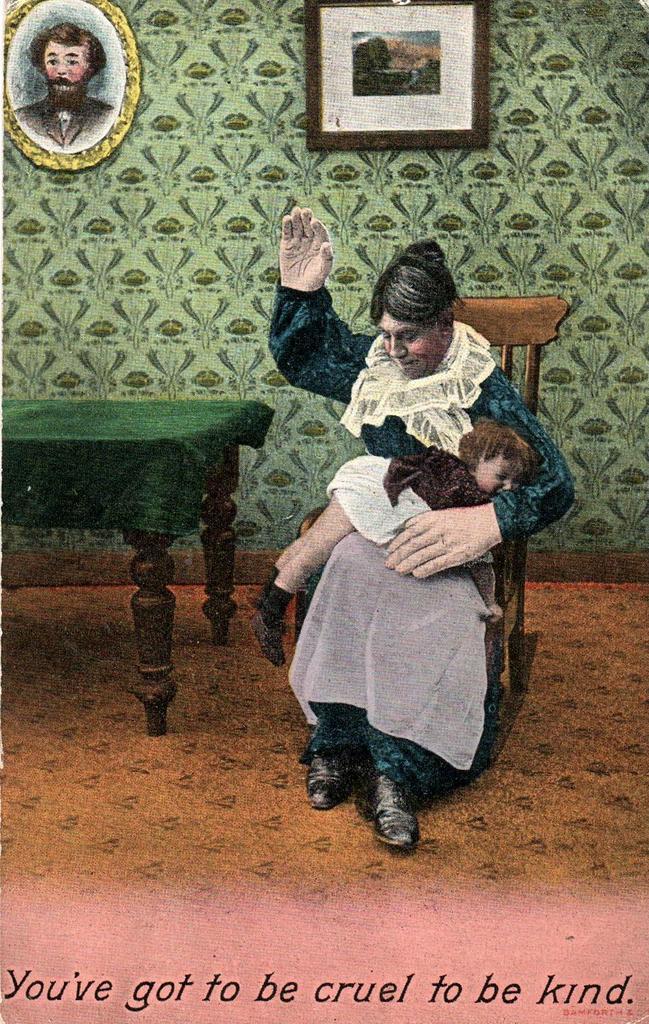Can you describe this image briefly? I can see this is a poster. In the poster there is a chair, a table ,a person and a child. There are photo frames attached to the wall. Also at the bottom of the image there is some text on it. 